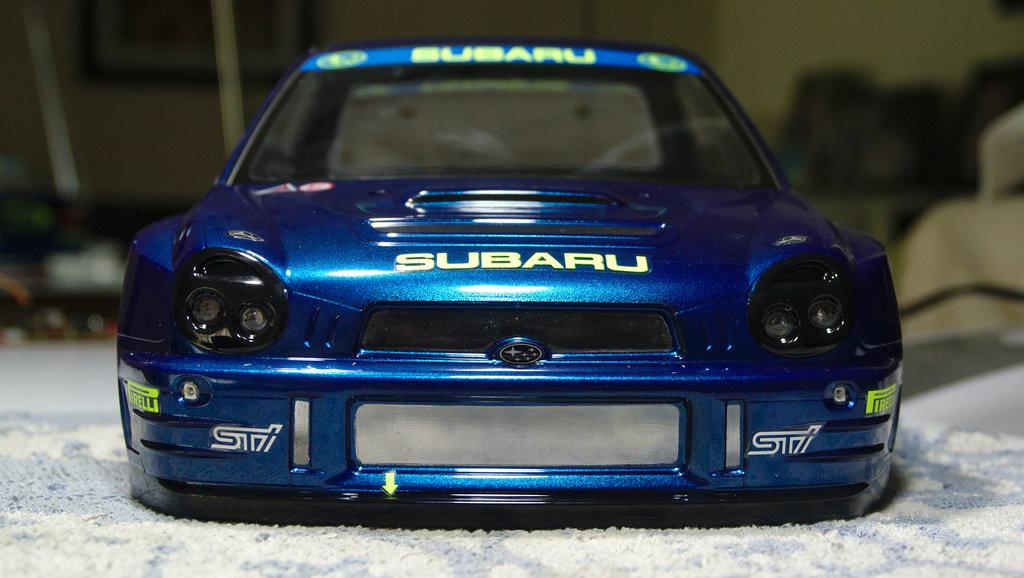What is the main subject of the image? There is a car in the image. What can be seen on the car? There is writing on the car. What is the color of the surface the car is on? The car is on a white surface. How would you describe the background of the image? The background of the image is blurred. How many ladybugs can be seen on the car in the image? There are no ladybugs present in the image; the car only has writing on it. What type of mask is the driver wearing in the image? There is no driver visible in the image, and therefore no mask can be observed. 